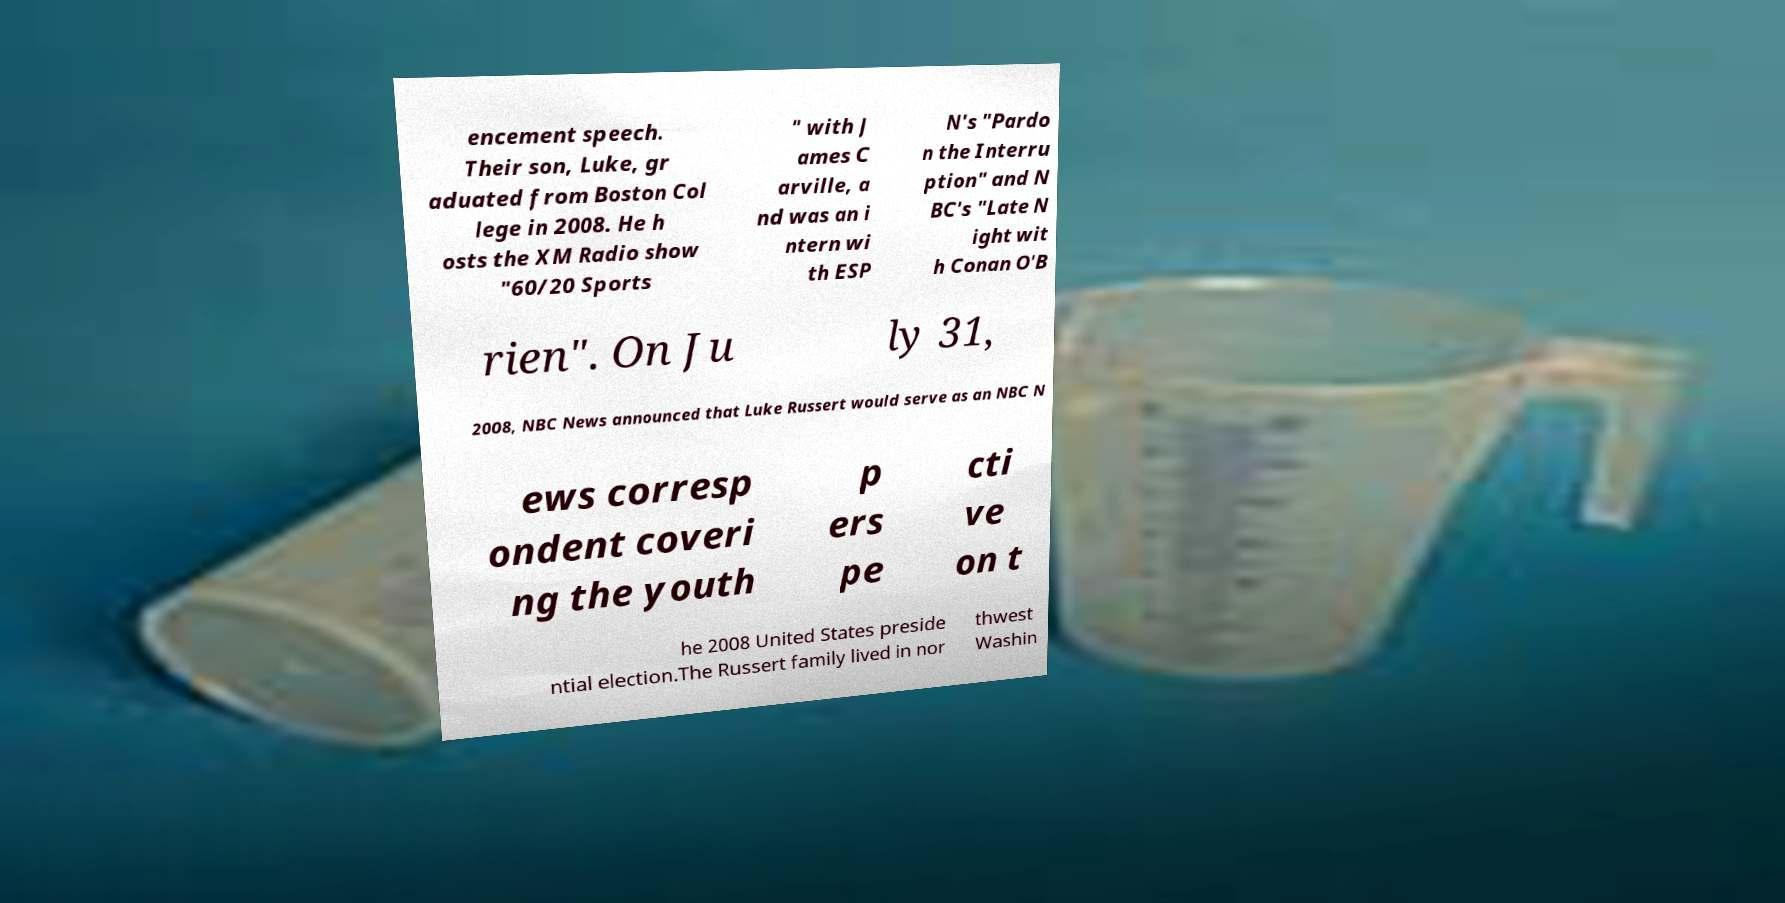Could you assist in decoding the text presented in this image and type it out clearly? encement speech. Their son, Luke, gr aduated from Boston Col lege in 2008. He h osts the XM Radio show "60/20 Sports " with J ames C arville, a nd was an i ntern wi th ESP N's "Pardo n the Interru ption" and N BC's "Late N ight wit h Conan O'B rien". On Ju ly 31, 2008, NBC News announced that Luke Russert would serve as an NBC N ews corresp ondent coveri ng the youth p ers pe cti ve on t he 2008 United States preside ntial election.The Russert family lived in nor thwest Washin 